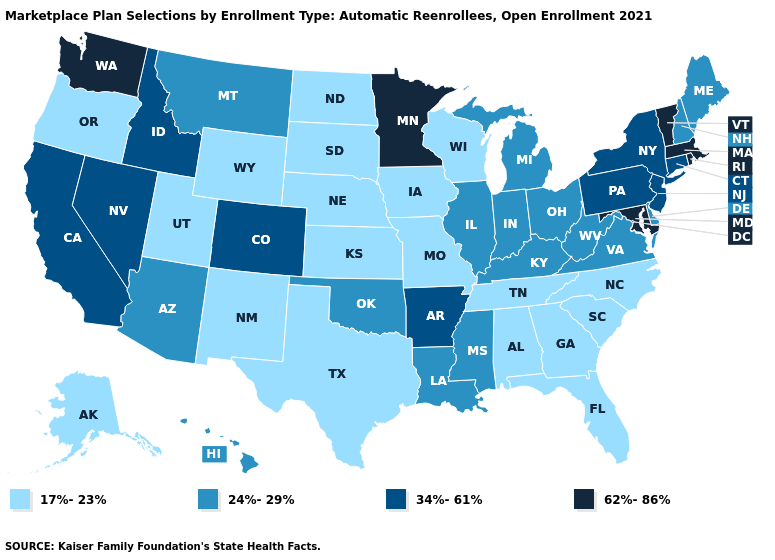What is the value of New Hampshire?
Concise answer only. 24%-29%. Among the states that border Virginia , which have the lowest value?
Concise answer only. North Carolina, Tennessee. Name the states that have a value in the range 34%-61%?
Answer briefly. Arkansas, California, Colorado, Connecticut, Idaho, Nevada, New Jersey, New York, Pennsylvania. Does New Hampshire have the lowest value in the Northeast?
Concise answer only. Yes. What is the value of Utah?
Answer briefly. 17%-23%. Does West Virginia have the highest value in the South?
Write a very short answer. No. Name the states that have a value in the range 34%-61%?
Write a very short answer. Arkansas, California, Colorado, Connecticut, Idaho, Nevada, New Jersey, New York, Pennsylvania. What is the highest value in states that border Pennsylvania?
Concise answer only. 62%-86%. What is the lowest value in the USA?
Write a very short answer. 17%-23%. Name the states that have a value in the range 17%-23%?
Be succinct. Alabama, Alaska, Florida, Georgia, Iowa, Kansas, Missouri, Nebraska, New Mexico, North Carolina, North Dakota, Oregon, South Carolina, South Dakota, Tennessee, Texas, Utah, Wisconsin, Wyoming. Does the first symbol in the legend represent the smallest category?
Short answer required. Yes. What is the highest value in the West ?
Short answer required. 62%-86%. What is the lowest value in the South?
Answer briefly. 17%-23%. Name the states that have a value in the range 34%-61%?
Quick response, please. Arkansas, California, Colorado, Connecticut, Idaho, Nevada, New Jersey, New York, Pennsylvania. What is the value of Maine?
Concise answer only. 24%-29%. 